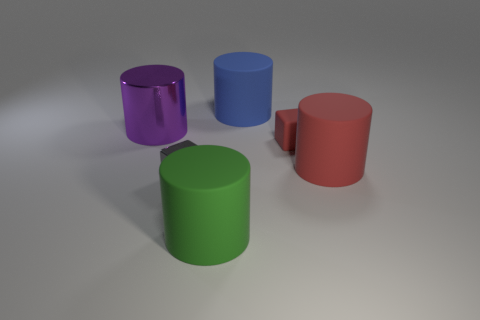Subtract all large metallic cylinders. How many cylinders are left? 3 Add 4 big metal objects. How many objects exist? 10 Subtract all gray blocks. How many blocks are left? 1 Subtract all cylinders. How many objects are left? 2 Subtract 1 blocks. How many blocks are left? 1 Add 5 small blocks. How many small blocks exist? 7 Subtract 0 blue spheres. How many objects are left? 6 Subtract all gray cubes. Subtract all brown balls. How many cubes are left? 1 Subtract all large green matte cylinders. Subtract all tiny red matte blocks. How many objects are left? 4 Add 3 blocks. How many blocks are left? 5 